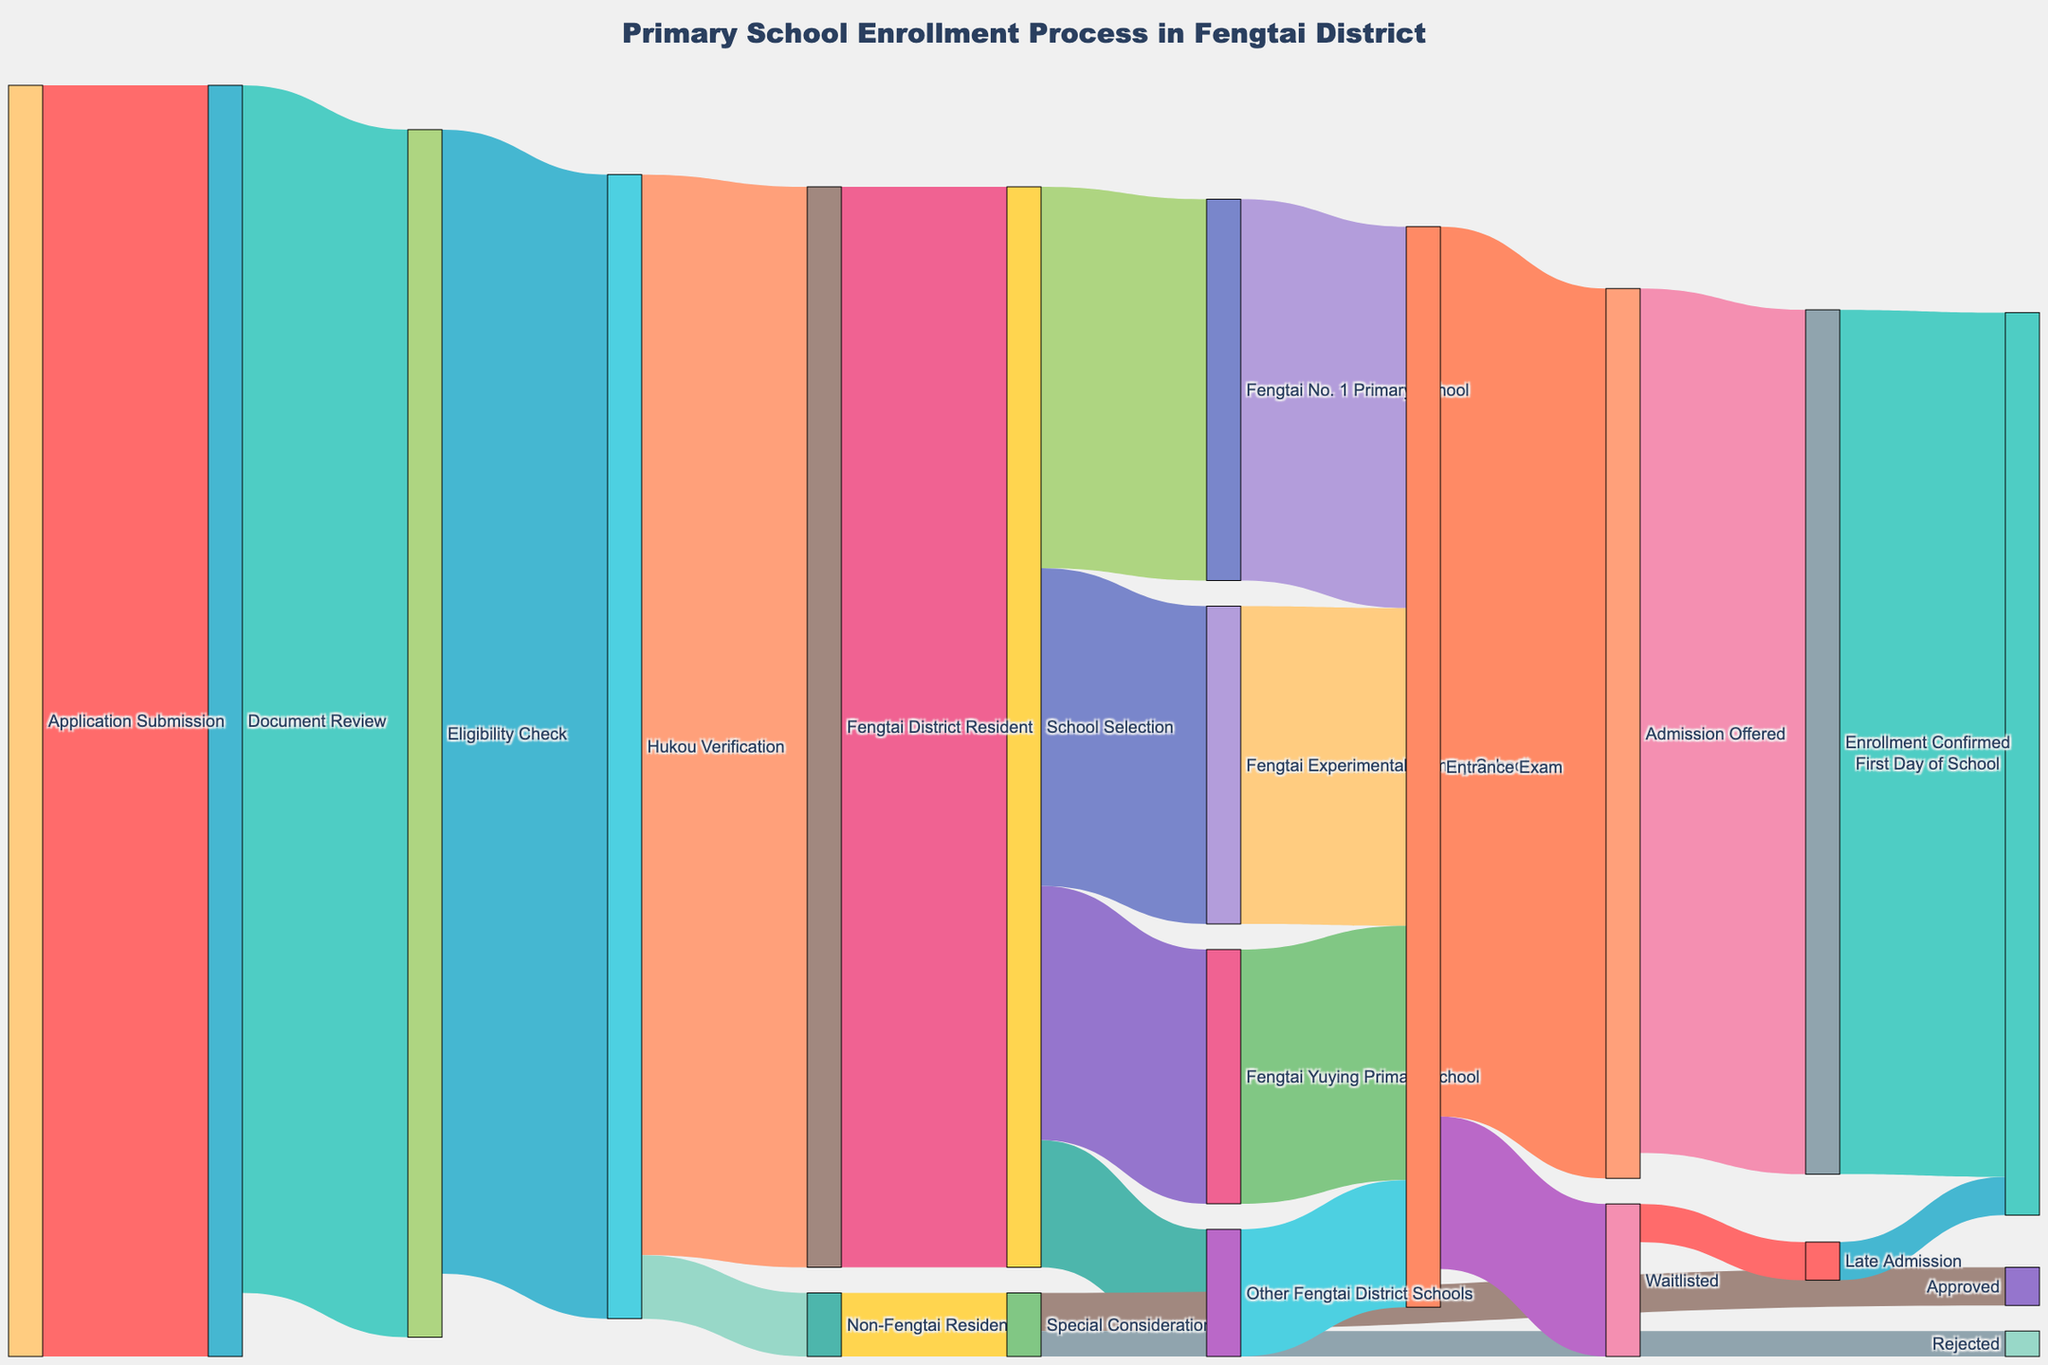How many students were involved in the initial Application Submission? The first step in the figure shows "Application Submission" leading to the next step with 1000 students.
Answer: 1000 How many students successfully passed the Eligibility Check? The figure shows that 950 students moved from Document Review to Eligibility Check; out of those, 900 passed the Eligibility Check and moved to the Hukou Verification stage.
Answer: 900 Out of the students who went through Hukou Verification, how many were recognized as Fengtai District Residents? From the figure, 900 went through Hukou Verification, and 850 were recognized as Fengtai District Residents.
Answer: 850 What is the total number of students who eventually entered different schools in Fengtai District? From the figure, 300 students went to Fengtai No. 1 Primary School, 250 went to Fengtai Experimental Primary School, 200 went to Fengtai Yuying Primary School, and 100 went to Other Fengtai District Schools. Summing these gives: 300 + 250 + 200 + 100 = 850.
Answer: 850 How many students got rejected after Special Consideration? The figure shows that from the Special Consideration section, 30 were approved and 20 were rejected.
Answer: 20 Which step had the highest number of students moving to the next in the process? The initial "Application Submission" sees 1000 students, which is the highest number at any step.
Answer: Application Submission How many students did not belong to Fengtai District after Hukou Verification? The figure indicates that after Hukou Verification, 50 students were marked as Non-Fengtai Residents.
Answer: 50 What proportion of applicants confirmed their enrollment after Admission was offered? The figure shows 700 students were offered admission, and 680 confirmed their enrollment. The proportion is 680/700.
Answer: 97.14% How many students were waitlisted after the Entrance Exam? The figure shows that 120 students were waitlisted after the Entrance Exam.
Answer: 120 After passing through special consideration, how many students eventually started the first day of school? The figure shows 30 students were approved through special consideration, and they all reached the first day of school stage.
Answer: 30 